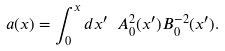Convert formula to latex. <formula><loc_0><loc_0><loc_500><loc_500>a ( x ) = \int _ { 0 } ^ { x } d x ^ { \prime } \ A _ { 0 } ^ { 2 } ( x ^ { \prime } ) B _ { 0 } ^ { - 2 } ( x ^ { \prime } ) .</formula> 